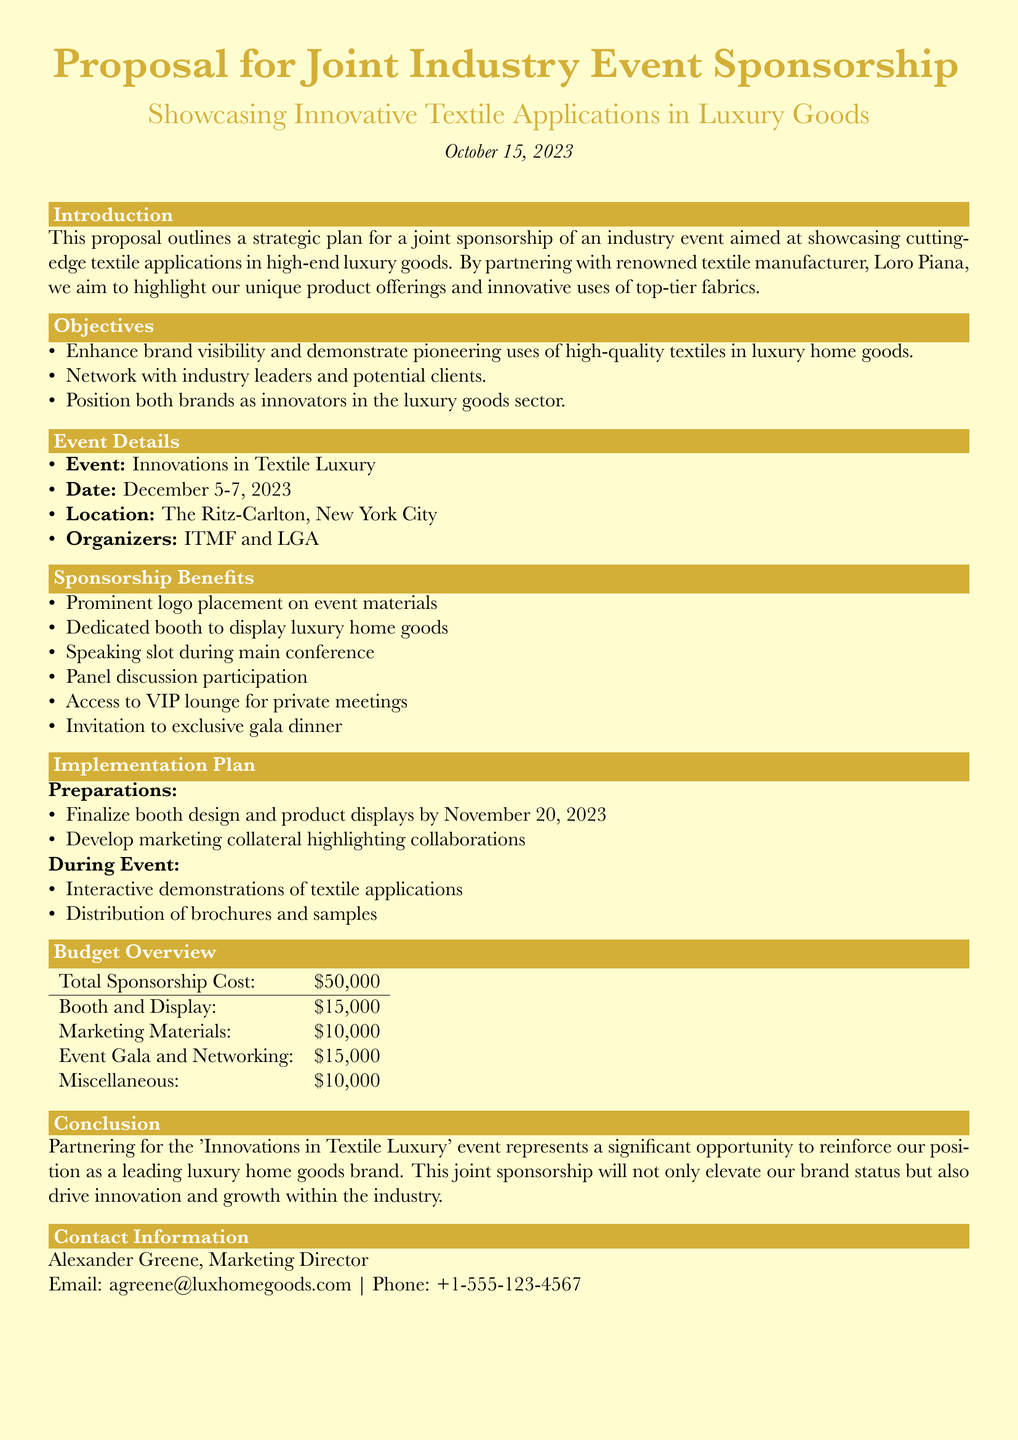what is the event date? The event date is specified as December 5-7, 2023.
Answer: December 5-7, 2023 who are the organizers of the event? The document mentions that the event is organized by ITMF and LGA.
Answer: ITMF and LGA what is the total sponsorship cost? The total sponsorship cost is clearly laid out in the budget overview as $50,000.
Answer: $50,000 what is one of the objectives of the sponsorship? An objective stated is to enhance brand visibility and demonstrate pioneering uses of high-quality textiles in luxury home goods.
Answer: Enhance brand visibility what benefits does the sponsorship include? One of the sponsorship benefits listed is a dedicated booth to display luxury home goods.
Answer: Dedicated booth why is the partnership for this event significant? The partnership is significant as it represents an opportunity to reinforce the brand's position and drive innovation within the industry.
Answer: Reinforce brand position what is the location of the event? The event location is specified in the document as The Ritz-Carlton, New York City.
Answer: The Ritz-Carlton, New York City when is the booth design finalized? The document states that the booth design and product displays should be finalized by November 20, 2023.
Answer: November 20, 2023 who is the contact person? The contact person listed in the document is Alexander Greene.
Answer: Alexander Greene 